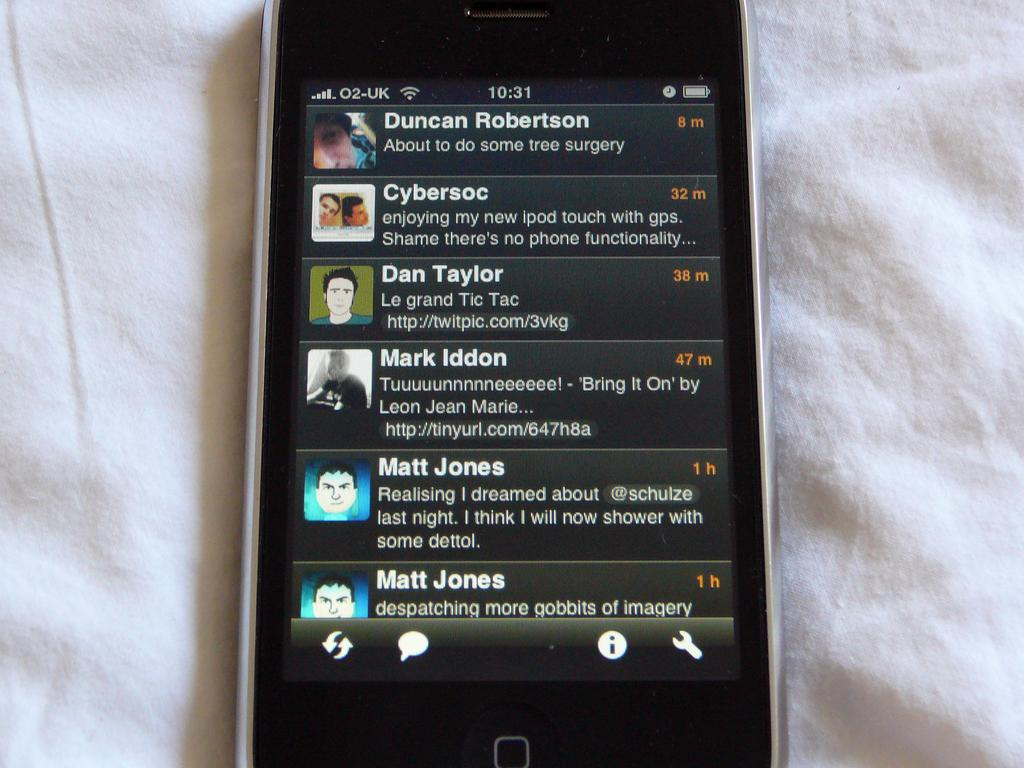<image>
Describe the image concisely. a phone that has the name Duncan Robertson on it 